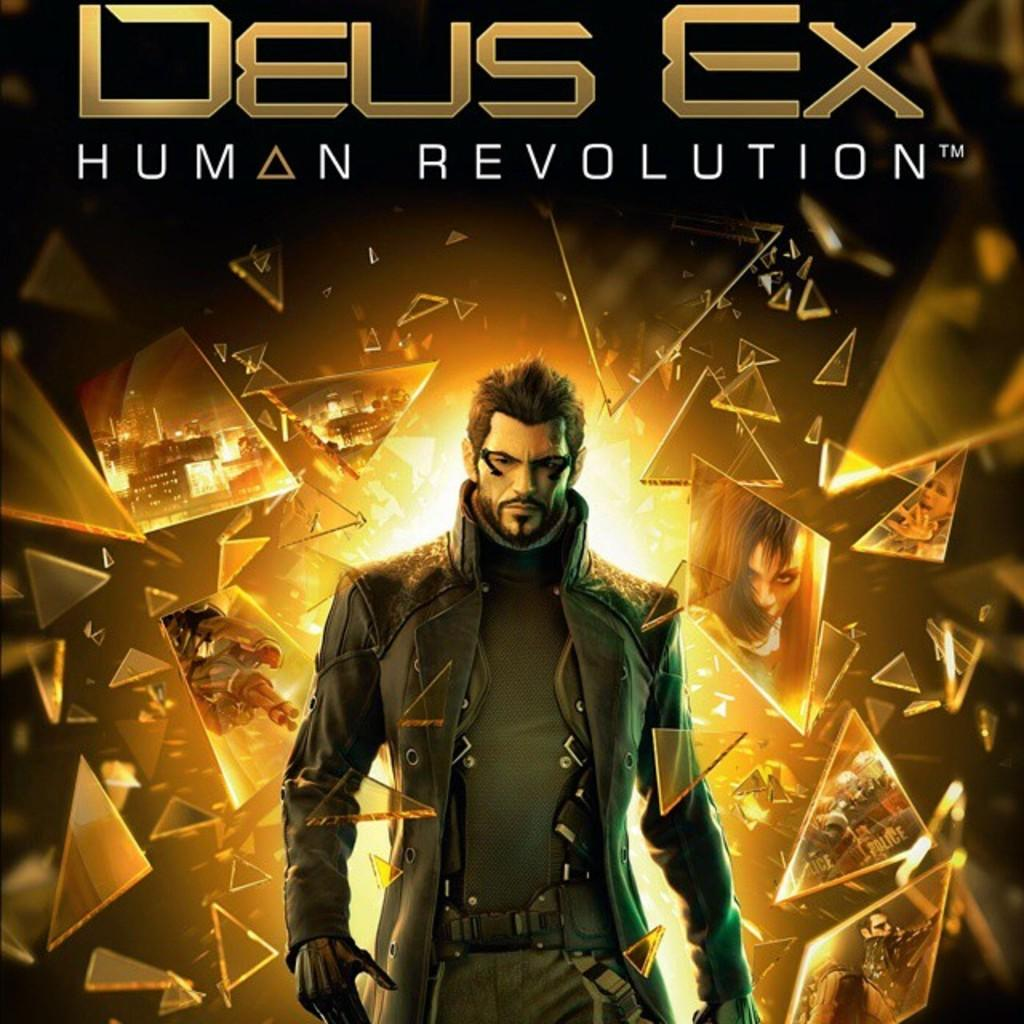Provide a one-sentence caption for the provided image. Deus ex human revolution poster with a man in the middle. 